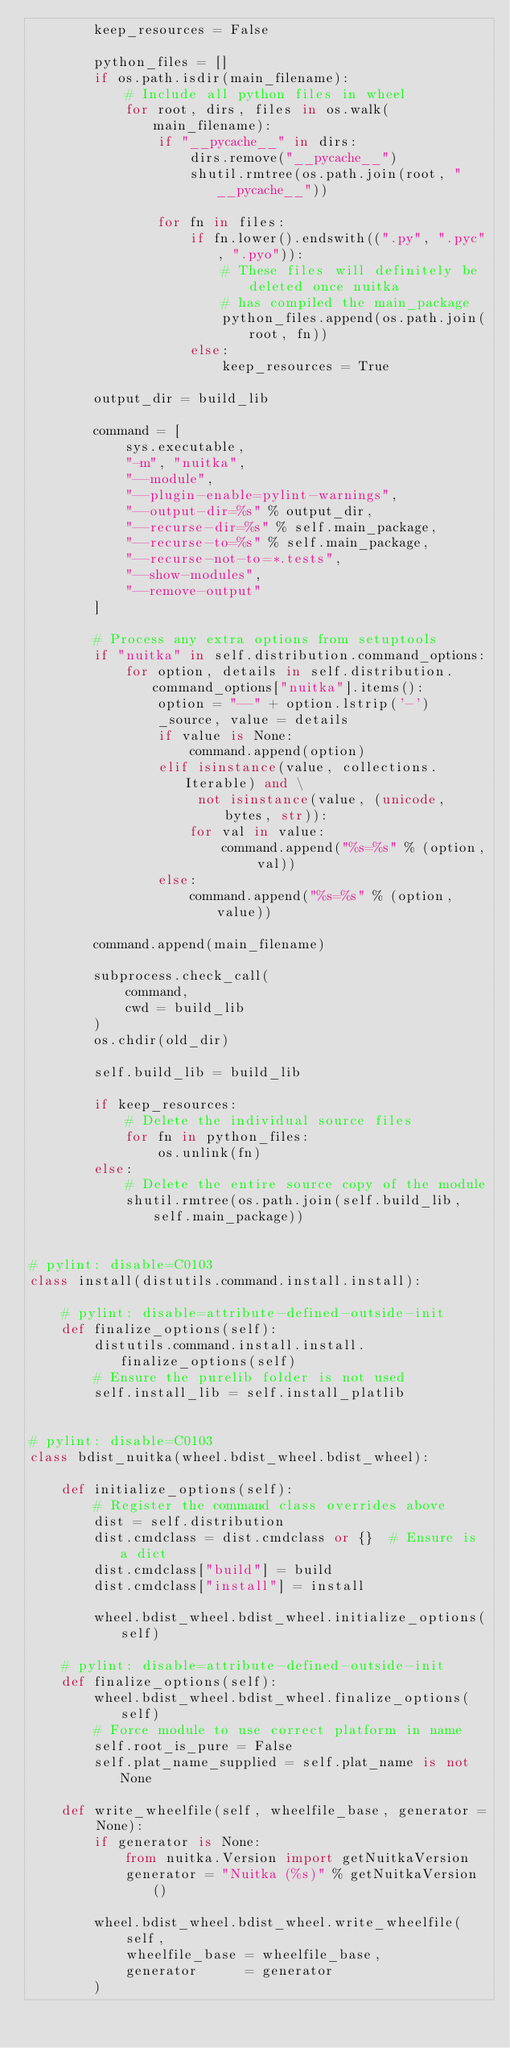Convert code to text. <code><loc_0><loc_0><loc_500><loc_500><_Python_>        keep_resources = False

        python_files = []
        if os.path.isdir(main_filename):
            # Include all python files in wheel
            for root, dirs, files in os.walk(main_filename):
                if "__pycache__" in dirs:
                    dirs.remove("__pycache__")
                    shutil.rmtree(os.path.join(root, "__pycache__"))

                for fn in files:
                    if fn.lower().endswith((".py", ".pyc", ".pyo")):
                        # These files will definitely be deleted once nuitka
                        # has compiled the main_package
                        python_files.append(os.path.join(root, fn))
                    else:
                        keep_resources = True

        output_dir = build_lib

        command = [
            sys.executable,
            "-m", "nuitka",
            "--module",
            "--plugin-enable=pylint-warnings",
            "--output-dir=%s" % output_dir,
            "--recurse-dir=%s" % self.main_package,
            "--recurse-to=%s" % self.main_package,
            "--recurse-not-to=*.tests",
            "--show-modules",
            "--remove-output"
        ]

        # Process any extra options from setuptools
        if "nuitka" in self.distribution.command_options:
            for option, details in self.distribution.command_options["nuitka"].items():
                option = "--" + option.lstrip('-')
                _source, value = details
                if value is None:
                    command.append(option)
                elif isinstance(value, collections.Iterable) and \
                     not isinstance(value, (unicode, bytes, str)):
                    for val in value:
                        command.append("%s=%s" % (option, val))
                else:
                    command.append("%s=%s" % (option, value))

        command.append(main_filename)

        subprocess.check_call(
            command,
            cwd = build_lib
        )
        os.chdir(old_dir)

        self.build_lib = build_lib

        if keep_resources:
            # Delete the individual source files
            for fn in python_files:
                os.unlink(fn)
        else:
            # Delete the entire source copy of the module
            shutil.rmtree(os.path.join(self.build_lib, self.main_package))


# pylint: disable=C0103
class install(distutils.command.install.install):

    # pylint: disable=attribute-defined-outside-init
    def finalize_options(self):
        distutils.command.install.install.finalize_options(self)
        # Ensure the purelib folder is not used
        self.install_lib = self.install_platlib


# pylint: disable=C0103
class bdist_nuitka(wheel.bdist_wheel.bdist_wheel):

    def initialize_options(self):
        # Register the command class overrides above
        dist = self.distribution
        dist.cmdclass = dist.cmdclass or {}  # Ensure is a dict
        dist.cmdclass["build"] = build
        dist.cmdclass["install"] = install

        wheel.bdist_wheel.bdist_wheel.initialize_options(self)

    # pylint: disable=attribute-defined-outside-init
    def finalize_options(self):
        wheel.bdist_wheel.bdist_wheel.finalize_options(self)
        # Force module to use correct platform in name
        self.root_is_pure = False
        self.plat_name_supplied = self.plat_name is not None

    def write_wheelfile(self, wheelfile_base, generator = None):
        if generator is None:
            from nuitka.Version import getNuitkaVersion
            generator = "Nuitka (%s)" % getNuitkaVersion()

        wheel.bdist_wheel.bdist_wheel.write_wheelfile(
            self,
            wheelfile_base = wheelfile_base,
            generator      = generator
        )
</code> 